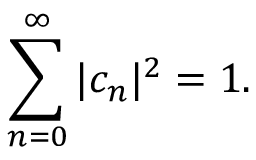<formula> <loc_0><loc_0><loc_500><loc_500>\sum _ { n = 0 } ^ { \infty } | c _ { n } | ^ { 2 } = 1 .</formula> 